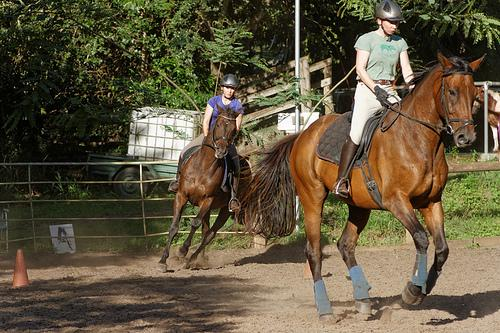What are the two people doing on the horses and what may be their level of experience? The two people are enjoying horseback riding and holding on tightly, suggesting they are experienced with horses. Describe the outfits worn by the two people in the image. One person is wearing a green shirt, white pants, and a gray helmet, while the other person is wearing a blue shirt, black pants, and a black helmet. What is the primary activity occurring within the image? Two people are riding brown horses and appear to be exercising or practicing in a horse arena. Explain the significance of the orange cone and white sign on the ground. The orange cone and white sign may be used for marking or guiding the horse-riding activity happening in the arena. What could be the reason for the horses' additional accessories like blankets and cloth on their legs? The blankets on the horses' backs and cloth on their legs could be used for protection, comfort, or added grip for the riders while practicing or competing. In what kind of environment are the horses and what may be the purpose of this activity? The horses are in a ranch inside a horse arena with a dirt ground, and they seem to be preparing for competition or exercising. Mention two interesting details about the horses in the image. The horses appear to be grown females and have black blankets on their backs and blue cloth on their legs. Describe the equestrian environment and the possible relationship between the riders and the horses. The riders and horses are in a ranch inside a horse arena, and the riders seem experienced with horses, suggesting a strong bond and familiarity between them. How many people and horses are in the image and what are they doing? There are two people riding two brown horses, exercising or practicing in a horse arena. What are the main objects in the image and their respective positions? Two horses and riders are at the center; an orange cone and white sign are on the ground; a metal fence, wooden ramp, and tall silver pole surround the area. Find the anomalies in the image. None Assess the quality of the image. good quality Which color cone can you see on the ground? orange Describe the emotions displayed by the people in the image. enjoying, experienced with horses Identify the colors of the shirts the people are wearing in the image. green, blue What color are the pants worn by the woman in the image? white List all the objects present on the horse's body in the image. tail, black blanket, blue cloth, black strap Are the horses being ridden by children? No Describe the setting of the image. horse arena, ranch, wooden ramp, metal fence Identify the objects interacting with the two people in the image. two brown horses, safety cone, wooden ramp, metal fence What are the horses doing in the image? running, being exercised, starting to run, preparing for competition Are the riders wearing helmets? Yes How many feet does the horse have? four Name the activities being performed by the two people in the image. riding horses, horseback riding, holding on tightly, exercising horses Which object appear in the background of the image? horse, wooden ramp, metal fence, tall silver pole What is the color of the two horses in the image? brown Identify the multiple captions for the object in the image with coordinates X:162, Y:15. two people riding horses, people riding brown horses, children sitting on horses, children riding horses, children riding brown horses, woman on a horse, woman riding a horse, two people are riding the horses, two people are enjoying horseback riding, the horses are starting to run, the riders are holding on tightly, the horses are preparing for competition What is the ground made of in the horse arena? dirt 